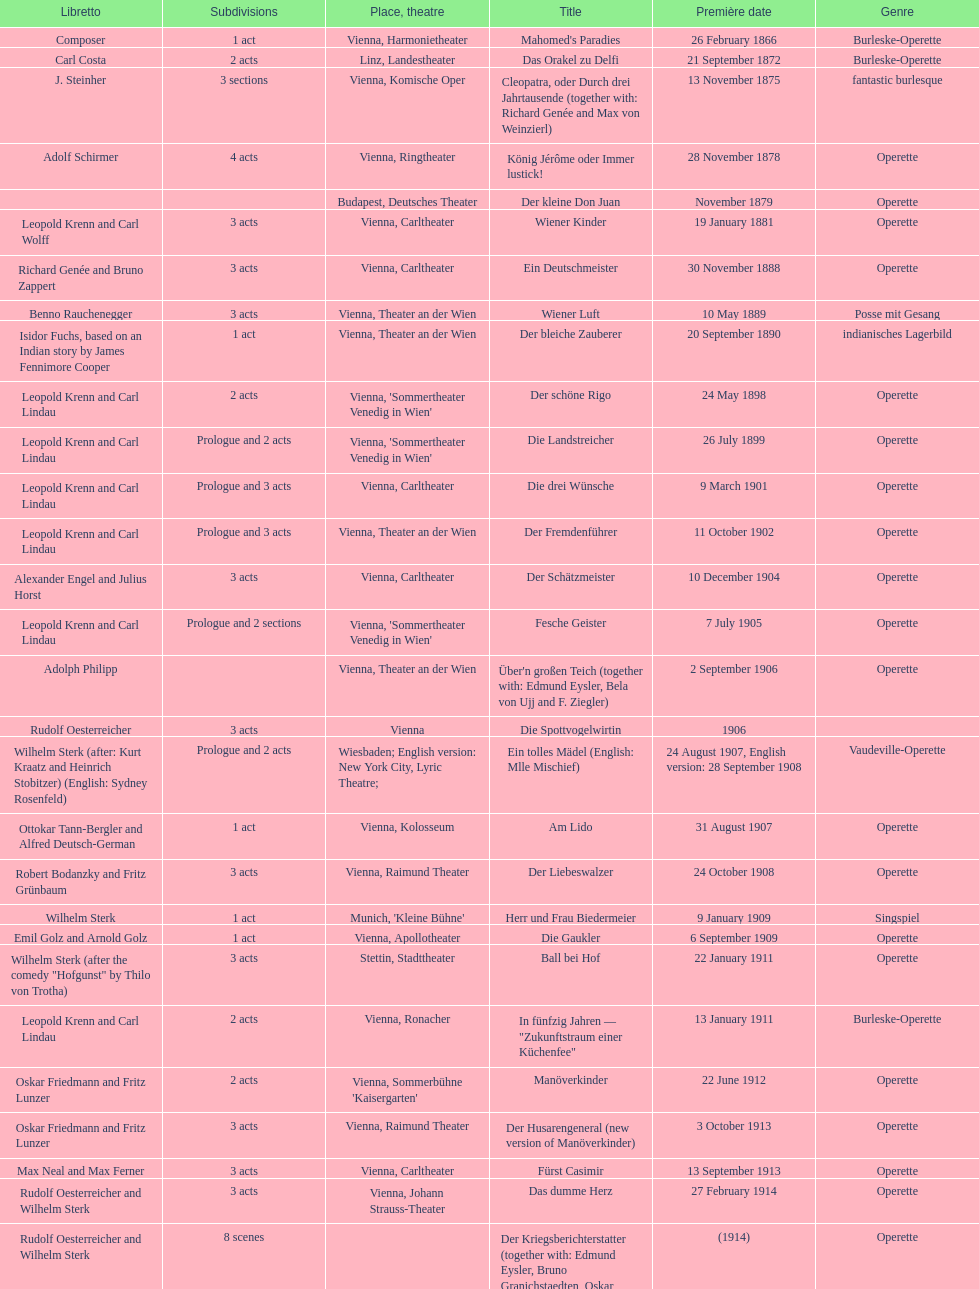All the dates are no later than what year? 1958. 